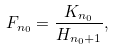<formula> <loc_0><loc_0><loc_500><loc_500>F _ { n _ { 0 } } = \frac { K _ { n _ { 0 } } } { H _ { n _ { 0 } + 1 } } ,</formula> 